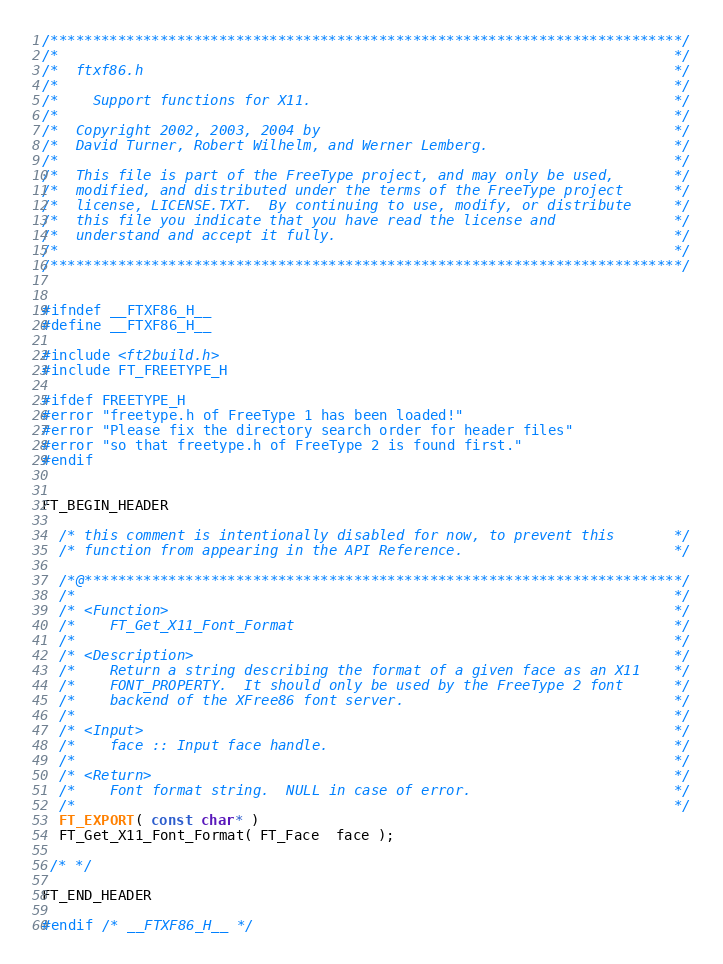Convert code to text. <code><loc_0><loc_0><loc_500><loc_500><_C_>/***************************************************************************/
/*                                                                         */
/*  ftxf86.h                                                               */
/*                                                                         */
/*    Support functions for X11.                                           */
/*                                                                         */
/*  Copyright 2002, 2003, 2004 by                                          */
/*  David Turner, Robert Wilhelm, and Werner Lemberg.                      */
/*                                                                         */
/*  This file is part of the FreeType project, and may only be used,       */
/*  modified, and distributed under the terms of the FreeType project      */
/*  license, LICENSE.TXT.  By continuing to use, modify, or distribute     */
/*  this file you indicate that you have read the license and              */
/*  understand and accept it fully.                                        */
/*                                                                         */
/***************************************************************************/


#ifndef __FTXF86_H__
#define __FTXF86_H__

#include <ft2build.h>
#include FT_FREETYPE_H

#ifdef FREETYPE_H
#error "freetype.h of FreeType 1 has been loaded!"
#error "Please fix the directory search order for header files"
#error "so that freetype.h of FreeType 2 is found first."
#endif


FT_BEGIN_HEADER

  /* this comment is intentionally disabled for now, to prevent this       */
  /* function from appearing in the API Reference.                         */

  /*@***********************************************************************/
  /*                                                                       */
  /* <Function>                                                            */
  /*    FT_Get_X11_Font_Format                                             */
  /*                                                                       */
  /* <Description>                                                         */
  /*    Return a string describing the format of a given face as an X11    */
  /*    FONT_PROPERTY.  It should only be used by the FreeType 2 font      */
  /*    backend of the XFree86 font server.                                */
  /*                                                                       */
  /* <Input>                                                               */
  /*    face :: Input face handle.                                         */
  /*                                                                       */
  /* <Return>                                                              */
  /*    Font format string.  NULL in case of error.                        */
  /*                                                                       */
  FT_EXPORT( const char* )
  FT_Get_X11_Font_Format( FT_Face  face );

 /* */

FT_END_HEADER

#endif /* __FTXF86_H__ */
</code> 